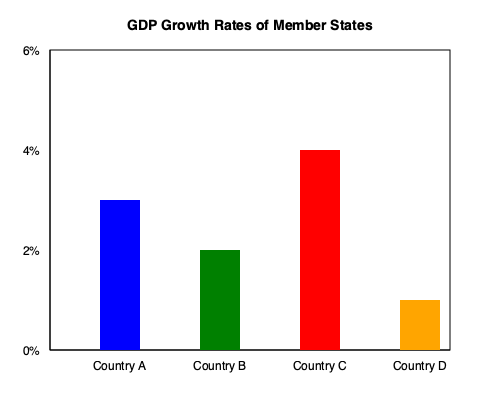As a UN official coordinating diplomatic efforts, you are analyzing the economic performance of four member states. Based on the bar graph showing GDP growth rates, which country would you prioritize for economic development assistance, and why? To answer this question, we need to analyze the GDP growth rates of the four countries shown in the bar graph:

1. Identify the GDP growth rates:
   - Country A (blue): 3%
   - Country B (green): 2%
   - Country C (red): 4%
   - Country D (orange): 1%

2. Compare the growth rates:
   Country D has the lowest growth rate at 1%, significantly lower than the others.

3. Consider the implications:
   - Lower growth rates often indicate economic challenges.
   - Countries with slower growth may struggle more with poverty reduction and development.

4. UN perspective:
   - The UN aims to promote sustainable development and reduce inequalities among nations.
   - Providing assistance to the country with the lowest growth rate aligns with these goals.

5. Diplomatic considerations:
   - Focusing on the country with the greatest need can demonstrate the UN's commitment to equitable development.
   - It may also help prevent widening economic gaps between member states.

Therefore, as a UN official, you would prioritize Country D for economic development assistance due to its significantly lower GDP growth rate compared to the other member states.
Answer: Country D, due to its lowest GDP growth rate of 1%. 